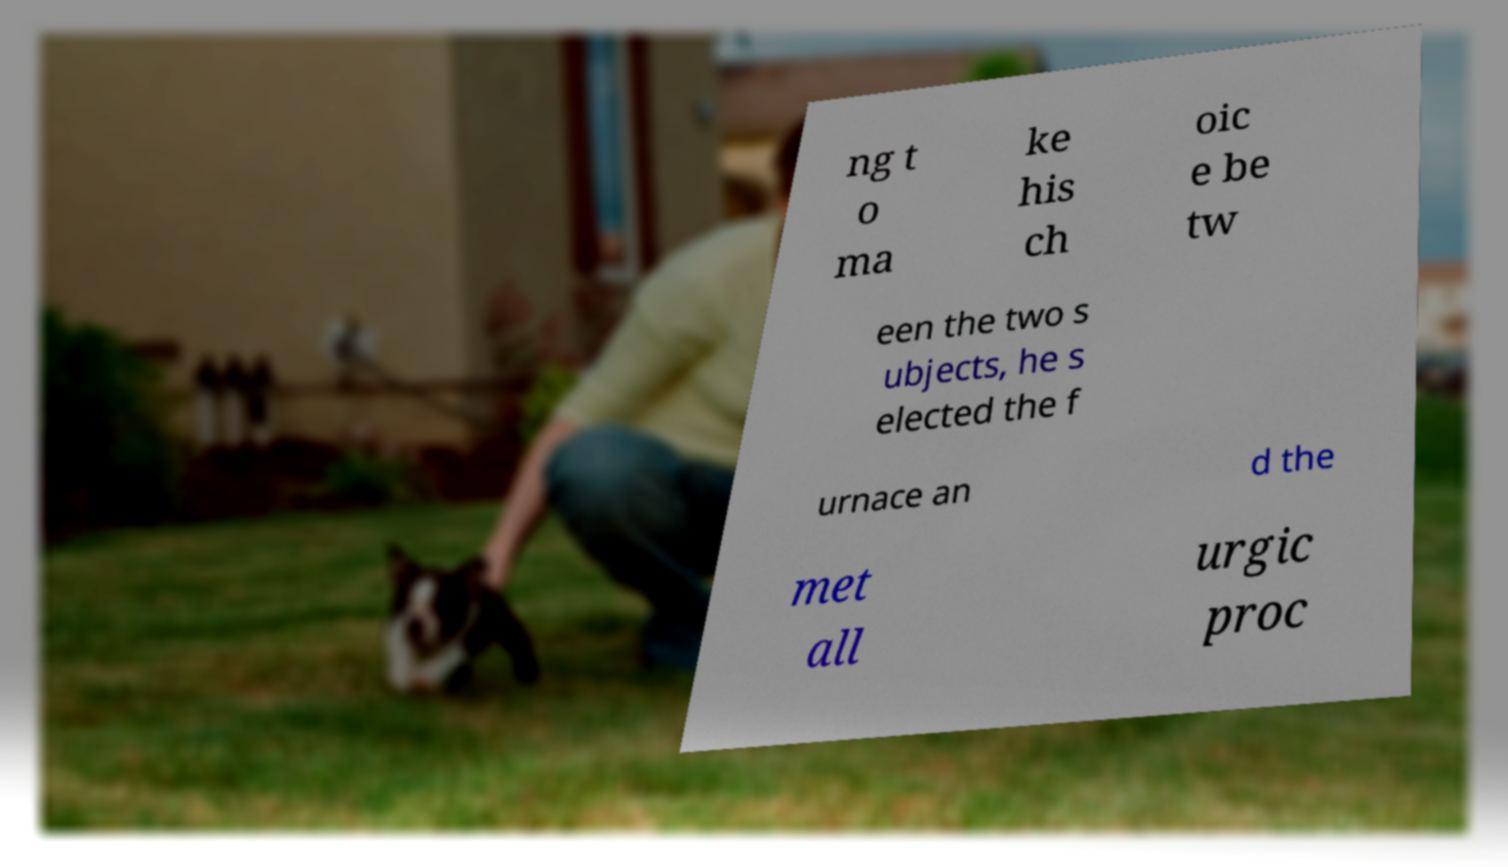Please read and relay the text visible in this image. What does it say? ng t o ma ke his ch oic e be tw een the two s ubjects, he s elected the f urnace an d the met all urgic proc 